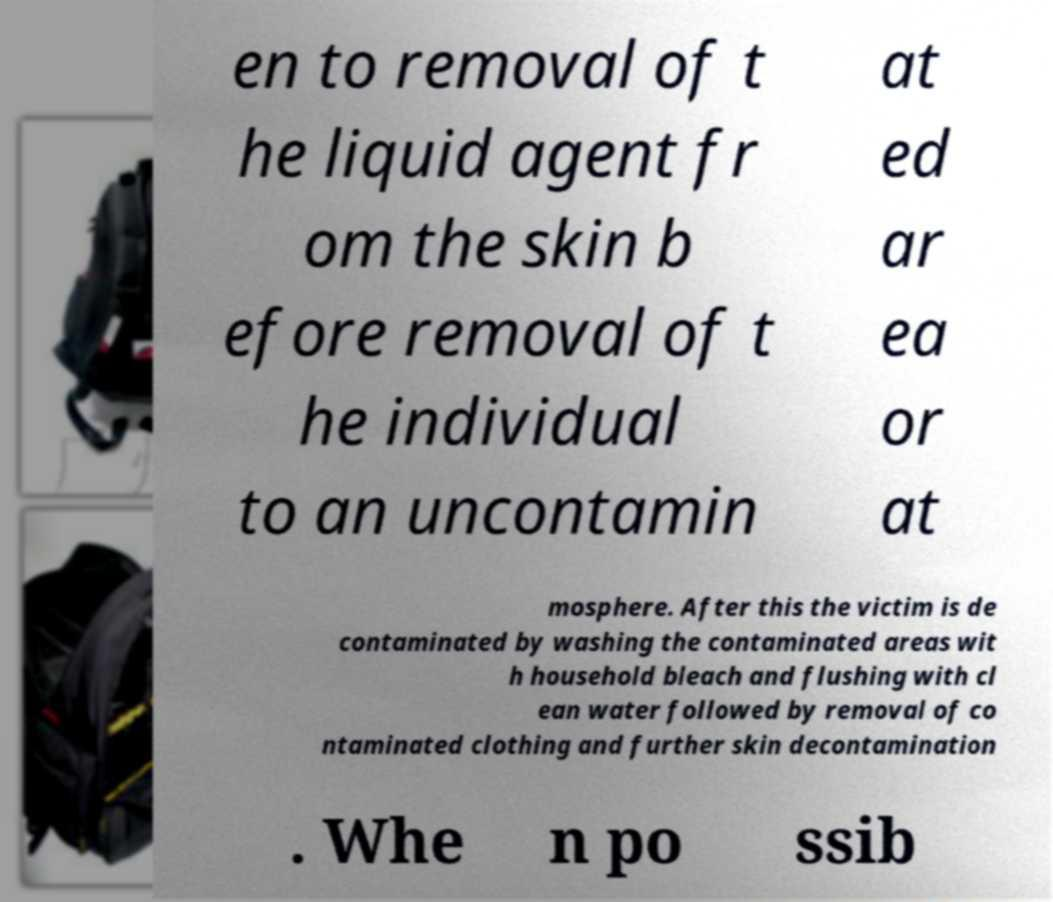Please identify and transcribe the text found in this image. en to removal of t he liquid agent fr om the skin b efore removal of t he individual to an uncontamin at ed ar ea or at mosphere. After this the victim is de contaminated by washing the contaminated areas wit h household bleach and flushing with cl ean water followed by removal of co ntaminated clothing and further skin decontamination . Whe n po ssib 